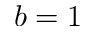Convert formula to latex. <formula><loc_0><loc_0><loc_500><loc_500>b = 1</formula> 